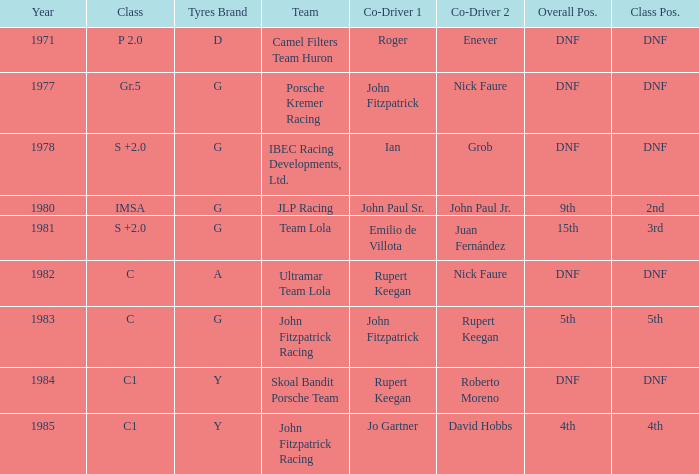Who was the co-driver that had a class position of 2nd? John Paul Sr. John Paul Jr. 